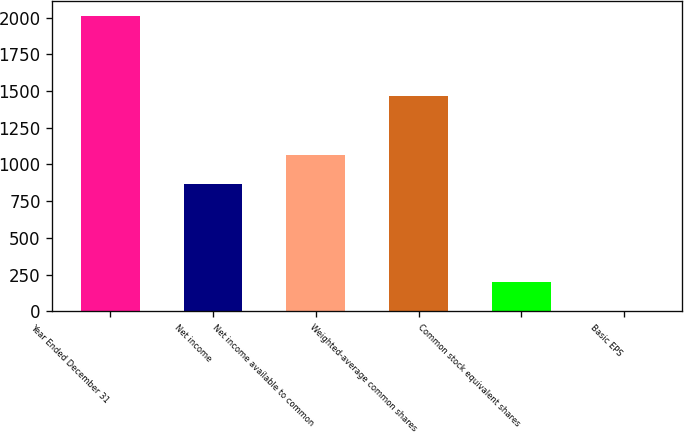<chart> <loc_0><loc_0><loc_500><loc_500><bar_chart><fcel>Year Ended December 31<fcel>Net income<fcel>Net income available to common<fcel>Weighted-average common shares<fcel>Common stock equivalent shares<fcel>Basic EPS<nl><fcel>2011<fcel>864<fcel>1065.03<fcel>1467.09<fcel>201.73<fcel>0.7<nl></chart> 